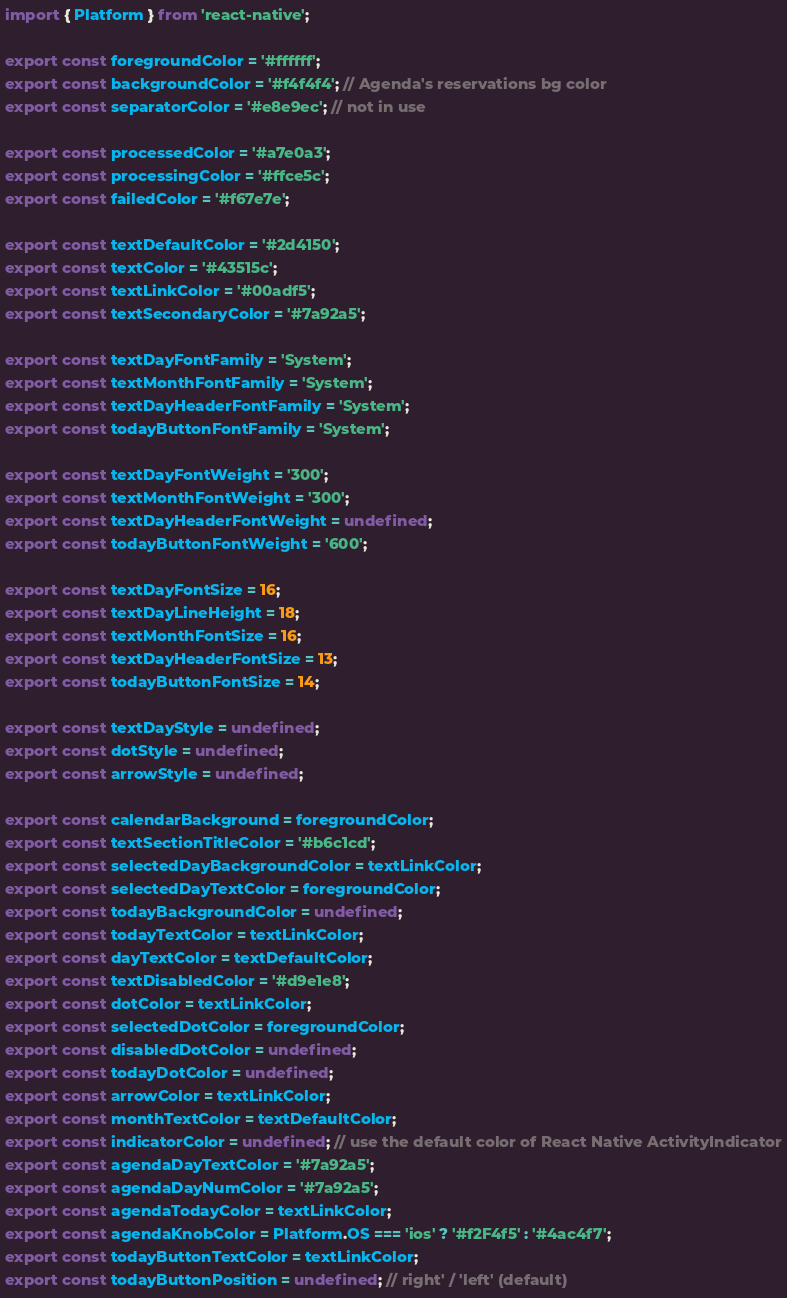<code> <loc_0><loc_0><loc_500><loc_500><_JavaScript_>import { Platform } from 'react-native';

export const foregroundColor = '#ffffff';
export const backgroundColor = '#f4f4f4'; // Agenda's reservations bg color
export const separatorColor = '#e8e9ec'; // not in use

export const processedColor = '#a7e0a3';
export const processingColor = '#ffce5c';
export const failedColor = '#f67e7e';

export const textDefaultColor = '#2d4150';
export const textColor = '#43515c';
export const textLinkColor = '#00adf5';
export const textSecondaryColor = '#7a92a5';

export const textDayFontFamily = 'System';
export const textMonthFontFamily = 'System';
export const textDayHeaderFontFamily = 'System';
export const todayButtonFontFamily = 'System';

export const textDayFontWeight = '300';
export const textMonthFontWeight = '300';
export const textDayHeaderFontWeight = undefined;
export const todayButtonFontWeight = '600';

export const textDayFontSize = 16;
export const textDayLineHeight = 18;
export const textMonthFontSize = 16;
export const textDayHeaderFontSize = 13;
export const todayButtonFontSize = 14;

export const textDayStyle = undefined;
export const dotStyle = undefined;
export const arrowStyle = undefined;

export const calendarBackground = foregroundColor;
export const textSectionTitleColor = '#b6c1cd';
export const selectedDayBackgroundColor = textLinkColor;
export const selectedDayTextColor = foregroundColor;
export const todayBackgroundColor = undefined;
export const todayTextColor = textLinkColor;
export const dayTextColor = textDefaultColor;
export const textDisabledColor = '#d9e1e8';
export const dotColor = textLinkColor;
export const selectedDotColor = foregroundColor;
export const disabledDotColor = undefined;
export const todayDotColor = undefined;
export const arrowColor = textLinkColor;
export const monthTextColor = textDefaultColor;
export const indicatorColor = undefined; // use the default color of React Native ActivityIndicator
export const agendaDayTextColor = '#7a92a5';
export const agendaDayNumColor = '#7a92a5';
export const agendaTodayColor = textLinkColor;
export const agendaKnobColor = Platform.OS === 'ios' ? '#f2F4f5' : '#4ac4f7';
export const todayButtonTextColor = textLinkColor;
export const todayButtonPosition = undefined; // right' / 'left' (default)
</code> 